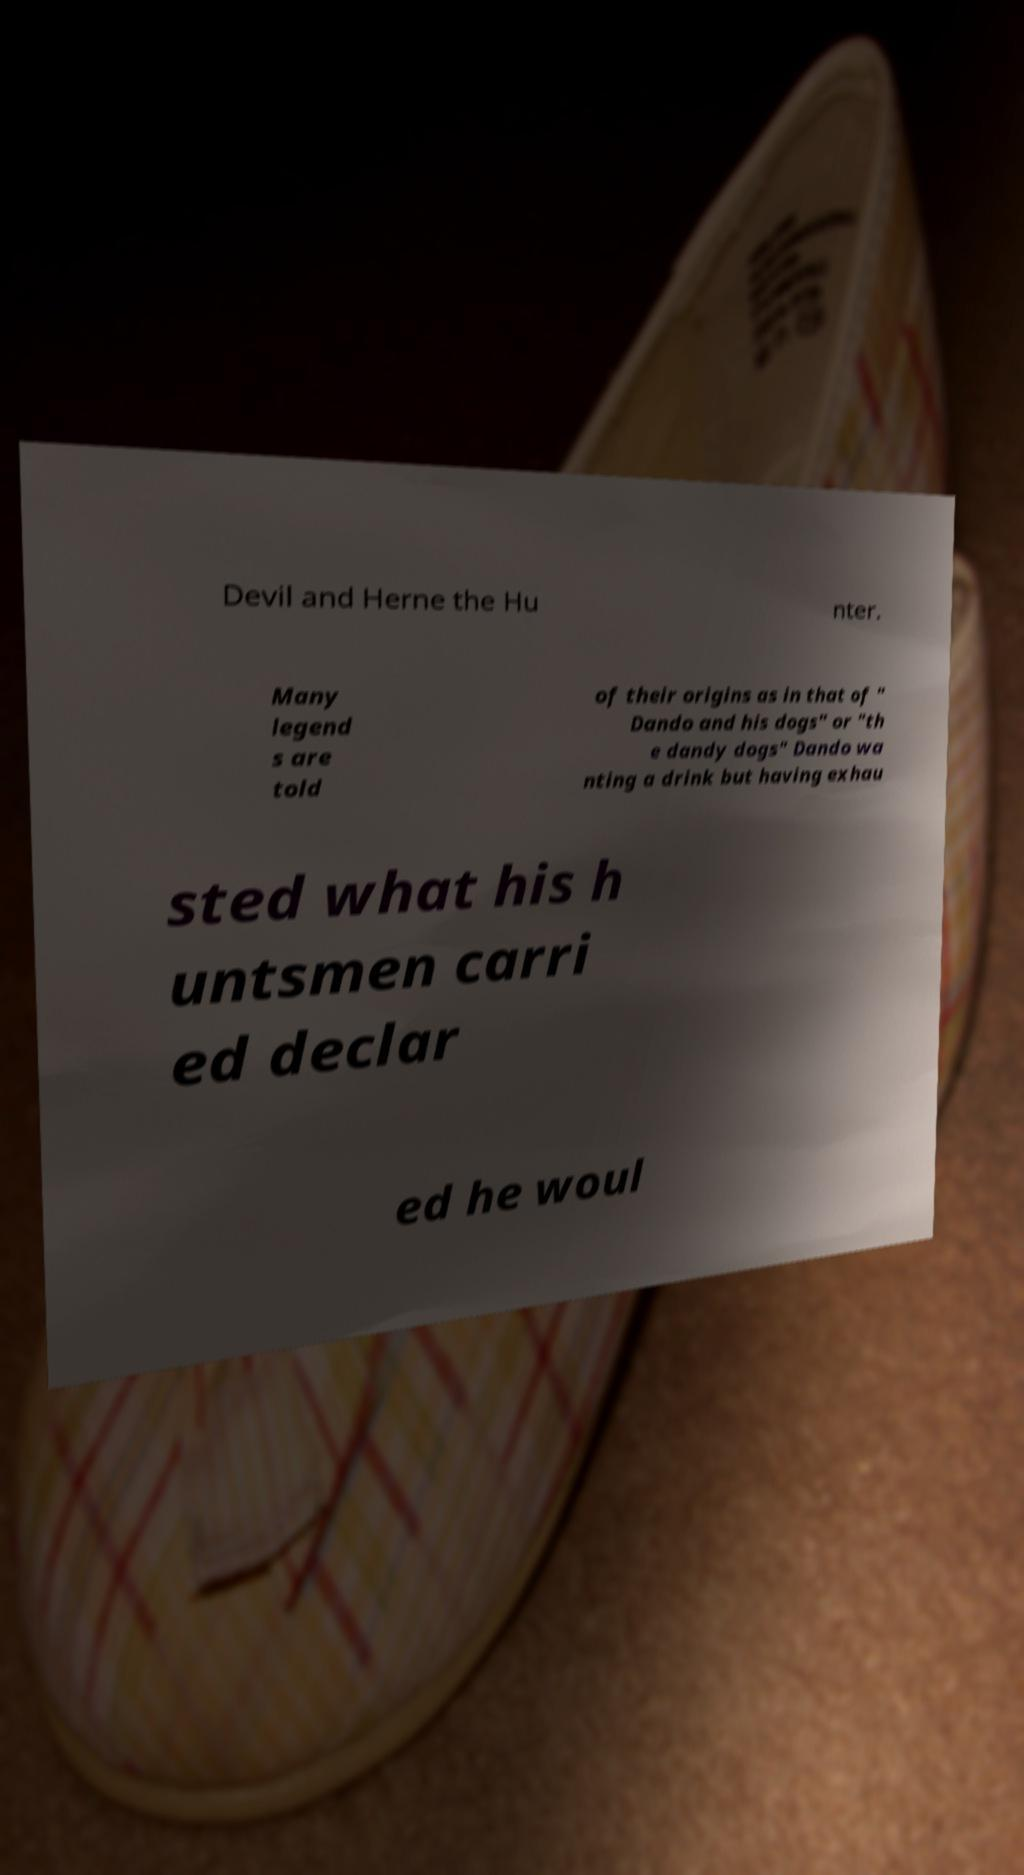I need the written content from this picture converted into text. Can you do that? Devil and Herne the Hu nter. Many legend s are told of their origins as in that of " Dando and his dogs" or "th e dandy dogs" Dando wa nting a drink but having exhau sted what his h untsmen carri ed declar ed he woul 